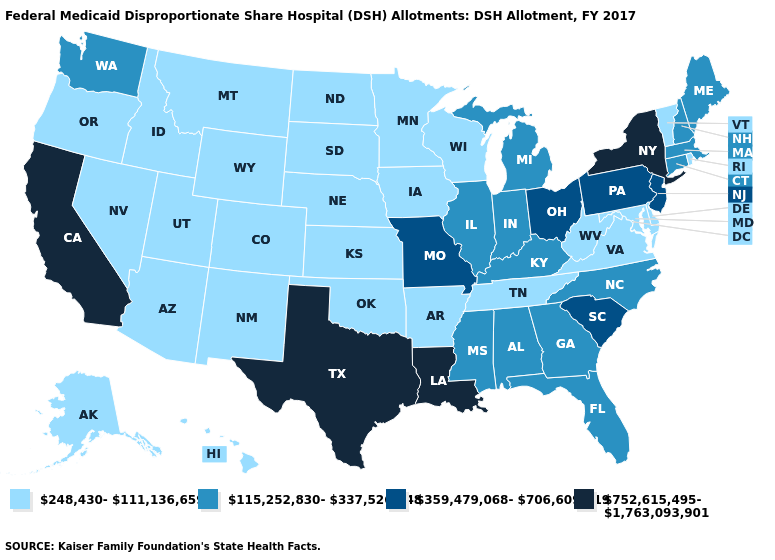Does Nebraska have the lowest value in the USA?
Short answer required. Yes. What is the highest value in the South ?
Give a very brief answer. 752,615,495-1,763,093,901. What is the value of New Jersey?
Quick response, please. 359,479,068-706,609,619. What is the value of South Carolina?
Short answer required. 359,479,068-706,609,619. What is the value of Utah?
Write a very short answer. 248,430-111,136,659. What is the lowest value in the West?
Write a very short answer. 248,430-111,136,659. Name the states that have a value in the range 115,252,830-337,526,148?
Give a very brief answer. Alabama, Connecticut, Florida, Georgia, Illinois, Indiana, Kentucky, Maine, Massachusetts, Michigan, Mississippi, New Hampshire, North Carolina, Washington. Name the states that have a value in the range 248,430-111,136,659?
Be succinct. Alaska, Arizona, Arkansas, Colorado, Delaware, Hawaii, Idaho, Iowa, Kansas, Maryland, Minnesota, Montana, Nebraska, Nevada, New Mexico, North Dakota, Oklahoma, Oregon, Rhode Island, South Dakota, Tennessee, Utah, Vermont, Virginia, West Virginia, Wisconsin, Wyoming. Name the states that have a value in the range 248,430-111,136,659?
Be succinct. Alaska, Arizona, Arkansas, Colorado, Delaware, Hawaii, Idaho, Iowa, Kansas, Maryland, Minnesota, Montana, Nebraska, Nevada, New Mexico, North Dakota, Oklahoma, Oregon, Rhode Island, South Dakota, Tennessee, Utah, Vermont, Virginia, West Virginia, Wisconsin, Wyoming. Is the legend a continuous bar?
Short answer required. No. Name the states that have a value in the range 752,615,495-1,763,093,901?
Keep it brief. California, Louisiana, New York, Texas. Name the states that have a value in the range 752,615,495-1,763,093,901?
Be succinct. California, Louisiana, New York, Texas. Which states have the highest value in the USA?
Short answer required. California, Louisiana, New York, Texas. Does the map have missing data?
Give a very brief answer. No. 